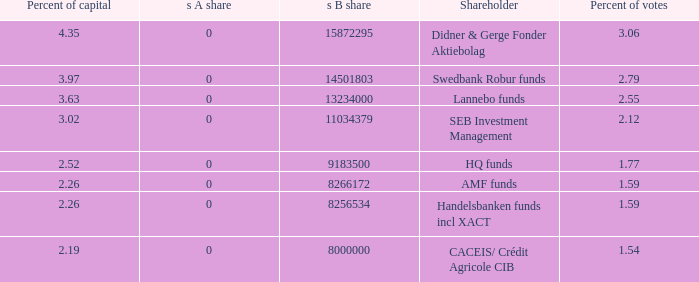What is the s B share for Handelsbanken funds incl XACT? 8256534.0. 